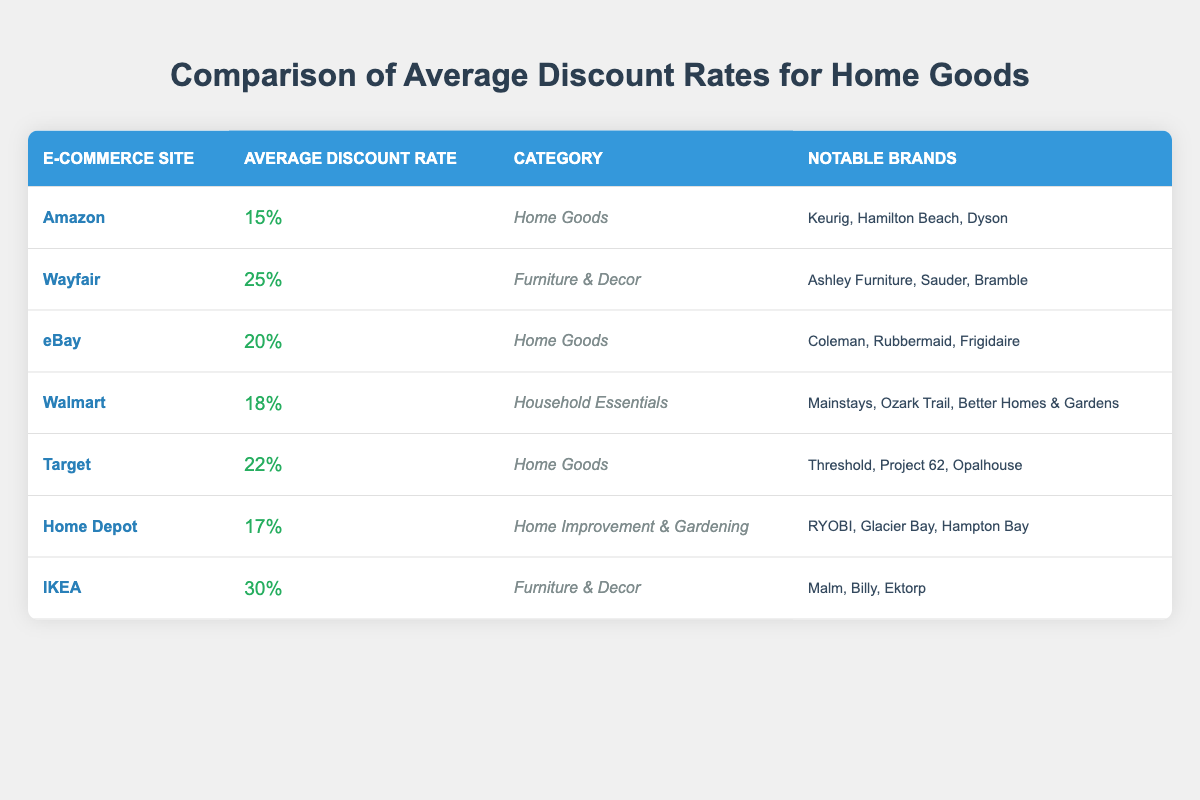What is the average discount rate on Amazon for home goods? According to the table, the average discount rate specifically for Amazon in the home goods category is listed as 15%.
Answer: 15% Which e-commerce site has the highest average discount rate for home goods? The table shows that IKEA has the highest average discount rate, which is 30%, but it is under the furniture & decor category. Among true home goods sites, Target at 22% is the highest.
Answer: Target (22%) Which site offers the lowest average discount rate, and what is it? The data indicates that Amazon has the lowest average discount rate at 15% within the home goods category.
Answer: Amazon (15%) If you combine the average discount rates of eBay and Walmart, what do you get? The average discount rate for eBay is 20% and for Walmart is 18%. Adding these together gives 20 + 18 = 38.
Answer: 38% True or False: Wayfair has a higher average discount rate than Target. The average discount rate for Wayfair is 25% while for Target it is 22%. Since 25% is greater than 22%, the statement is true.
Answer: True Calculation: What is the difference between the highest and lowest average discount rates from the e-commerce sites listed? The highest average discount rate is 30% from IKEA, and the lowest is 15% from Amazon. The difference is 30 - 15 = 15%.
Answer: 15% Which site has notable brands including "Threshold" and "Project 62"? The table states that Threshold and Project 62 are notable brands associated with the Target site.
Answer: Target Which category has the highest average discount rate overall? By examining the average discount rates, IKEA in the Furniture & Decor category has 30%, which is the highest discount rate across all categories in the table.
Answer: Furniture & Decor (30%) How does the average discount rate of Home Depot compare to that of Target? Home Depot has an average discount rate of 17%, while Target offers a higher rate of 22%. Therefore, Target's rate is greater than Home Depot's.
Answer: Target's rate is higher What are the notable brands available on Walmart? The table lists the notable brands available on Walmart as Mainstays, Ozark Trail, and Better Homes & Gardens.
Answer: Mainstays, Ozark Trail, Better Homes & Gardens 